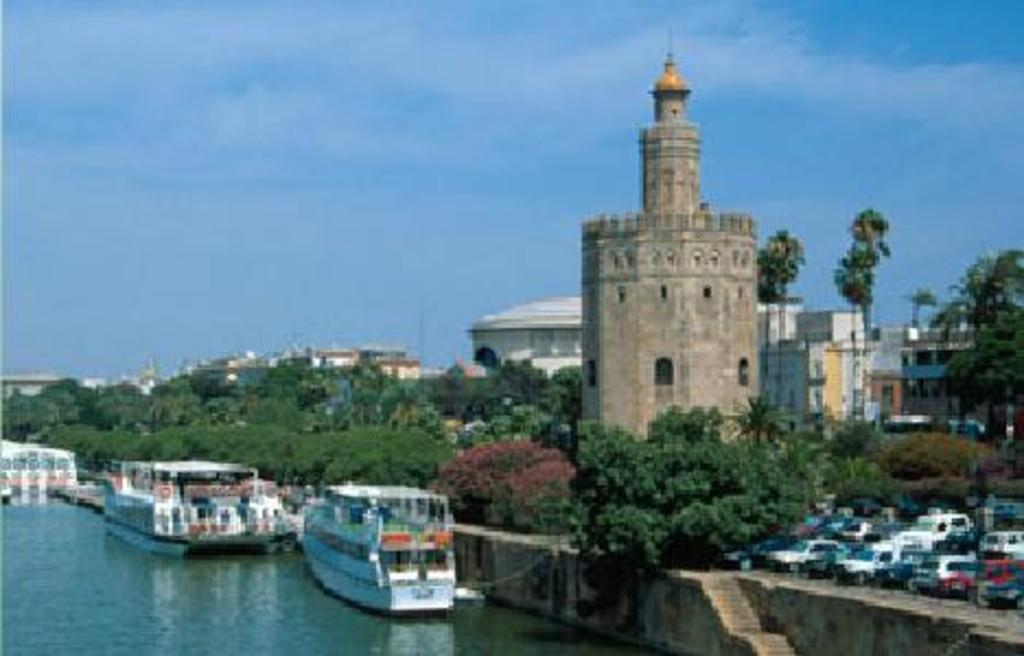What type of natural elements can be seen in the image? There are trees in the image. What type of structure is present in the image? There is a tower and buildings in the image. What type of transportation is visible in the image? There are cars in the image. What architectural feature can be seen at the bottom of the image? There are stairs at the bottom of the image. What type of vehicles can be seen in the water at the bottom of the image? There are boats in the water at the bottom of the image. What can be seen in the background of the image? In the background, there is sky and ground. What type of love can be seen between the trees and the tower in the image? There is no love depicted between the trees and the tower in the image; it is a visual representation of objects and structures. What type of event is taking place in the image? There is no specific event taking place in the image; it is a general scene featuring various elements. 